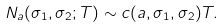<formula> <loc_0><loc_0><loc_500><loc_500>N _ { a } ( \sigma _ { 1 } , \sigma _ { 2 } ; T ) \sim c ( a , \sigma _ { 1 } , \sigma _ { 2 } ) T .</formula> 